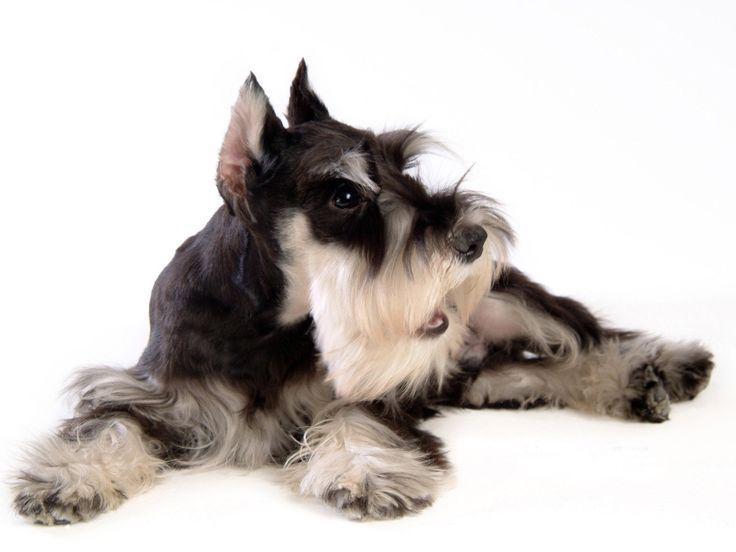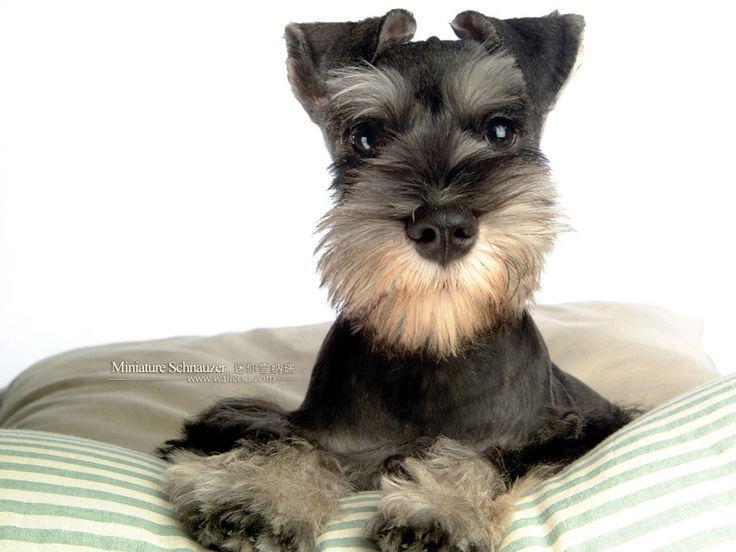The first image is the image on the left, the second image is the image on the right. Evaluate the accuracy of this statement regarding the images: "There is at least one dog completely surrounded by whiteness with no shadows of its tail.". Is it true? Answer yes or no. Yes. 